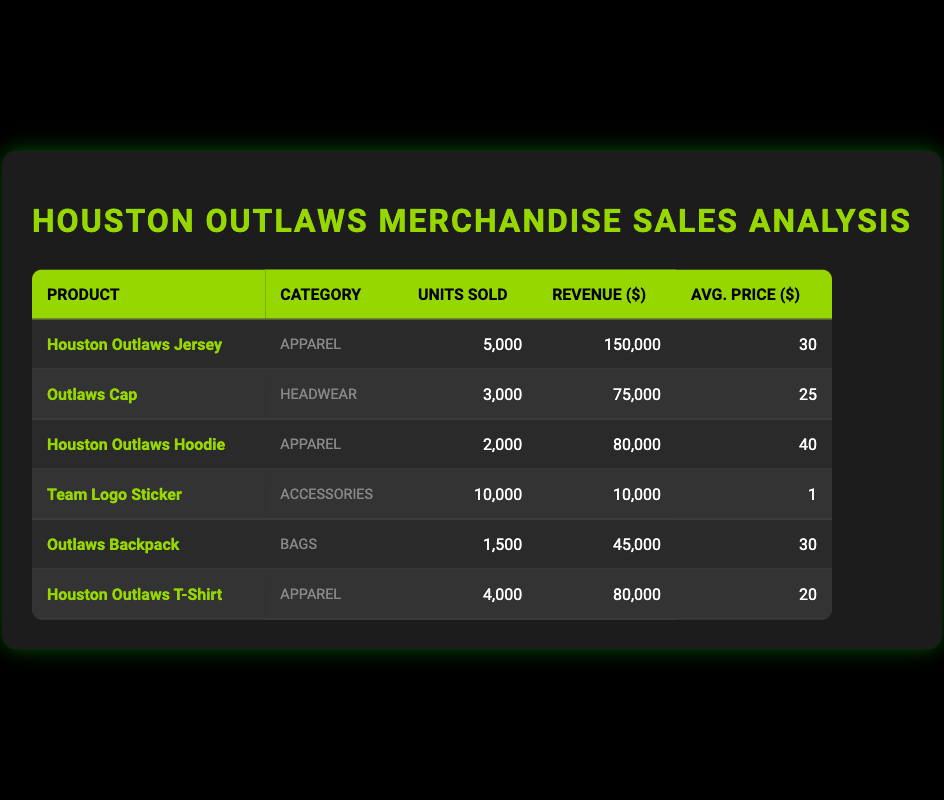What is the total revenue generated from all merchandise sales? To find the total revenue, I will sum up the 'revenue_generated' values from all products listed in the table: 150000 + 75000 + 80000 + 10000 + 45000 + 80000 = 400000
Answer: 400000 Which product sold the most units? The product with the highest 'units_sold' value is the "Team Logo Sticker" with 10000 units sold.
Answer: Team Logo Sticker What is the average revenue generated per unit sold for the Houston Outlaws Jersey? The revenue generated by the Houston Outlaws Jersey is 150000, and it sold 5000 units. The average revenue per unit is calculated as 150000 / 5000 = 30.
Answer: 30 Is the average price of the Outlaws Cap higher than the average price of the Houston Outlaws T-Shirt? The average price of the Outlaws Cap is 25, while the average price of the Houston Outlaws T-Shirt is 20. Since 25 is greater than 20, the statement is true.
Answer: Yes What is the total number of units sold across all apparel items? There are three apparel items: the Houston Outlaws Jersey (5000), the Houston Outlaws Hoodie (2000), and the Houston Outlaws T-Shirt (4000). The total units sold for apparel is calculated by summing these values: 5000 + 2000 + 4000 = 11000.
Answer: 11000 Does the revenue from the Outlaws Backpack exceed the revenue from the Team Logo Sticker? The revenue generated from the Outlaws Backpack is 45000, and the revenue from the Team Logo Sticker is 10000. Since 45000 is greater than 10000, the answer is true.
Answer: Yes What percentage of the total revenue is generated by the Outlaws Cap? First, I find the total revenue which is 400000. The revenue from the Outlaws Cap is 75000. The percentage is calculated as (75000 / 400000) * 100, which equals 18.75%.
Answer: 18.75 What is the average unit price of merchandise in the 'Bags' category? The only product in the 'Bags' category is the Outlaws Backpack, with an average price of 30. Thus, the average price in this category is 30.
Answer: 30 Are there more units sold of Houston Outlaws Apparel compared to Headwear? Houston Outlaws Apparel (Jersey, Hoodie, T-Shirt) sold a total of 5000 + 2000 + 4000 = 11000 units. The Outlaws Cap in Headwear sold 3000 units. Since 11000 is greater than 3000, the answer is true.
Answer: Yes 